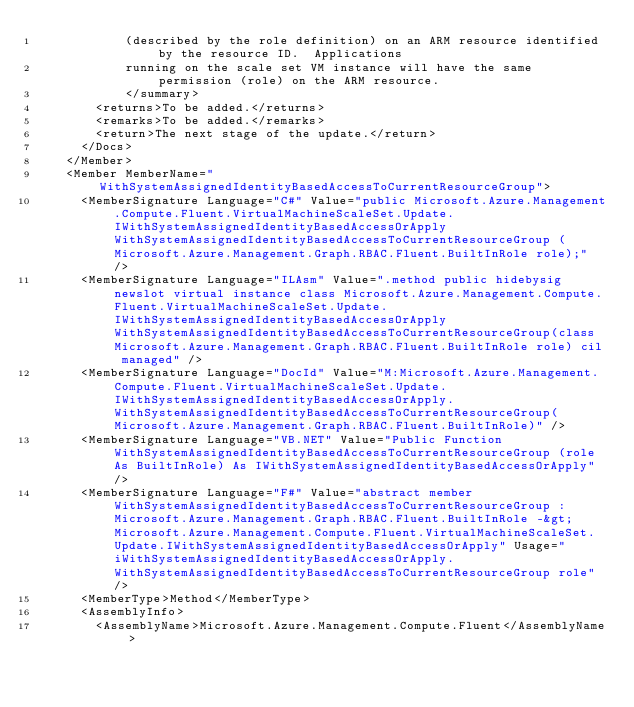Convert code to text. <code><loc_0><loc_0><loc_500><loc_500><_XML_>            (described by the role definition) on an ARM resource identified by the resource ID.  Applications
            running on the scale set VM instance will have the same permission (role) on the ARM resource.
            </summary>
        <returns>To be added.</returns>
        <remarks>To be added.</remarks>
        <return>The next stage of the update.</return>
      </Docs>
    </Member>
    <Member MemberName="WithSystemAssignedIdentityBasedAccessToCurrentResourceGroup">
      <MemberSignature Language="C#" Value="public Microsoft.Azure.Management.Compute.Fluent.VirtualMachineScaleSet.Update.IWithSystemAssignedIdentityBasedAccessOrApply WithSystemAssignedIdentityBasedAccessToCurrentResourceGroup (Microsoft.Azure.Management.Graph.RBAC.Fluent.BuiltInRole role);" />
      <MemberSignature Language="ILAsm" Value=".method public hidebysig newslot virtual instance class Microsoft.Azure.Management.Compute.Fluent.VirtualMachineScaleSet.Update.IWithSystemAssignedIdentityBasedAccessOrApply WithSystemAssignedIdentityBasedAccessToCurrentResourceGroup(class Microsoft.Azure.Management.Graph.RBAC.Fluent.BuiltInRole role) cil managed" />
      <MemberSignature Language="DocId" Value="M:Microsoft.Azure.Management.Compute.Fluent.VirtualMachineScaleSet.Update.IWithSystemAssignedIdentityBasedAccessOrApply.WithSystemAssignedIdentityBasedAccessToCurrentResourceGroup(Microsoft.Azure.Management.Graph.RBAC.Fluent.BuiltInRole)" />
      <MemberSignature Language="VB.NET" Value="Public Function WithSystemAssignedIdentityBasedAccessToCurrentResourceGroup (role As BuiltInRole) As IWithSystemAssignedIdentityBasedAccessOrApply" />
      <MemberSignature Language="F#" Value="abstract member WithSystemAssignedIdentityBasedAccessToCurrentResourceGroup : Microsoft.Azure.Management.Graph.RBAC.Fluent.BuiltInRole -&gt; Microsoft.Azure.Management.Compute.Fluent.VirtualMachineScaleSet.Update.IWithSystemAssignedIdentityBasedAccessOrApply" Usage="iWithSystemAssignedIdentityBasedAccessOrApply.WithSystemAssignedIdentityBasedAccessToCurrentResourceGroup role" />
      <MemberType>Method</MemberType>
      <AssemblyInfo>
        <AssemblyName>Microsoft.Azure.Management.Compute.Fluent</AssemblyName></code> 